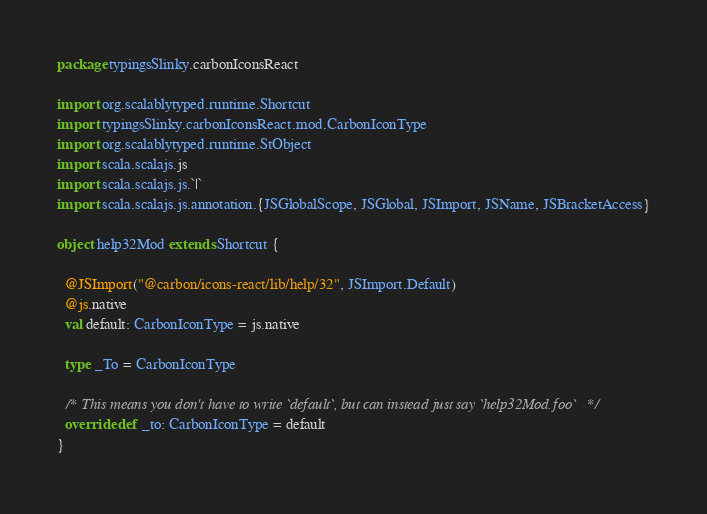<code> <loc_0><loc_0><loc_500><loc_500><_Scala_>package typingsSlinky.carbonIconsReact

import org.scalablytyped.runtime.Shortcut
import typingsSlinky.carbonIconsReact.mod.CarbonIconType
import org.scalablytyped.runtime.StObject
import scala.scalajs.js
import scala.scalajs.js.`|`
import scala.scalajs.js.annotation.{JSGlobalScope, JSGlobal, JSImport, JSName, JSBracketAccess}

object help32Mod extends Shortcut {
  
  @JSImport("@carbon/icons-react/lib/help/32", JSImport.Default)
  @js.native
  val default: CarbonIconType = js.native
  
  type _To = CarbonIconType
  
  /* This means you don't have to write `default`, but can instead just say `help32Mod.foo` */
  override def _to: CarbonIconType = default
}
</code> 